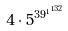<formula> <loc_0><loc_0><loc_500><loc_500>4 \cdot 5 ^ { { 3 9 ^ { 1 } } ^ { 1 3 2 } }</formula> 